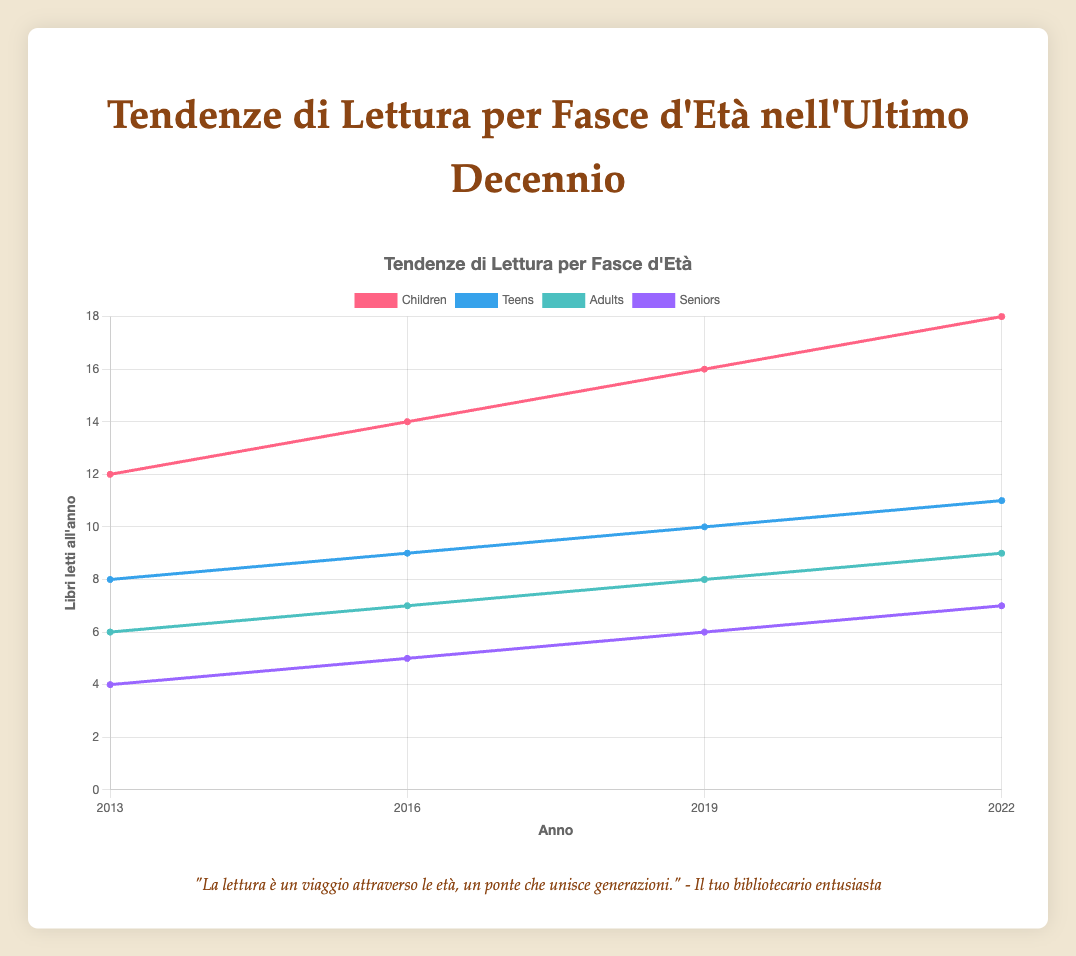What is the trend in the number of books read per year by children from 2013 to 2022? The number of books read by children increases steadily: 12 books in 2013, 14 in 2016, 16 in 2019, and 18 in 2022.
Answer: Increasing Between children and teens, which group read more books per year in 2019? In 2019, children read 16 books per year while teens read 10.
Answer: Children What is the average number of books read per year by adults over the decade? Summing the number of books read by adults in 2013, 2016, 2019, and 2022 and dividing by 4: (6 + 7 + 8 + 9) / 4 = 7.5
Answer: 7.5 Which age group had the highest increase in the percentage of digital books from 2013 to 2022? By comparing the increase for each group: Children: 30-15 = 15%, Teens: 40-25 = 15%, Adults: 38-20 = 18%, Seniors: 25-10 = 15%, Adults have the highest increase.
Answer: Adults Which year saw the largest increase in books read by seniors compared to the previous recorded year? The increases are: 2016-2013 = 5 - 4 = 1, 2019-2016 = 6 - 5 = 1, 2022-2019 = 7 - 6 = 1, all years see a 1 book increase.
Answer: No largest increase, all are 1 book What is the total number of books read by all age groups combined in 2016? Summing books from all groups in 2016: 14 (Children) + 9 (Teens) + 7 (Adults) + 5 (Seniors) = 35
Answer: 35 Did any age group see a decrease in the number of books read per year in any recorded period? All age groups show either steady or increasing trends from 2013 to 2022.
Answer: No Between 2013 and 2022, which age group consistently read more books per year than seniors? All age groups (Children, Teens, Adults) read more books consistently than Seniors over the years.
Answer: Children, Teens, Adults 